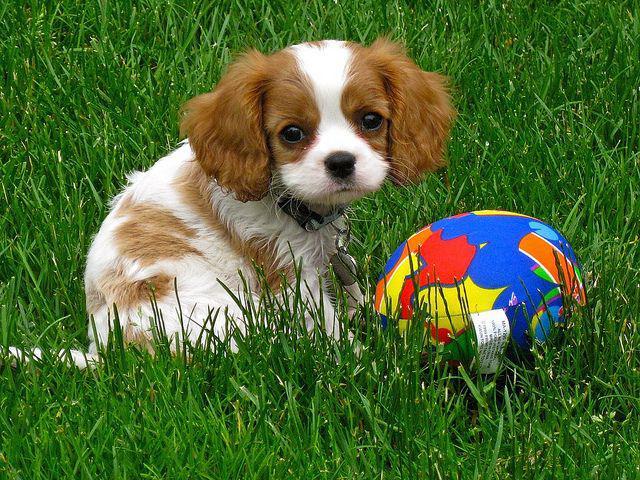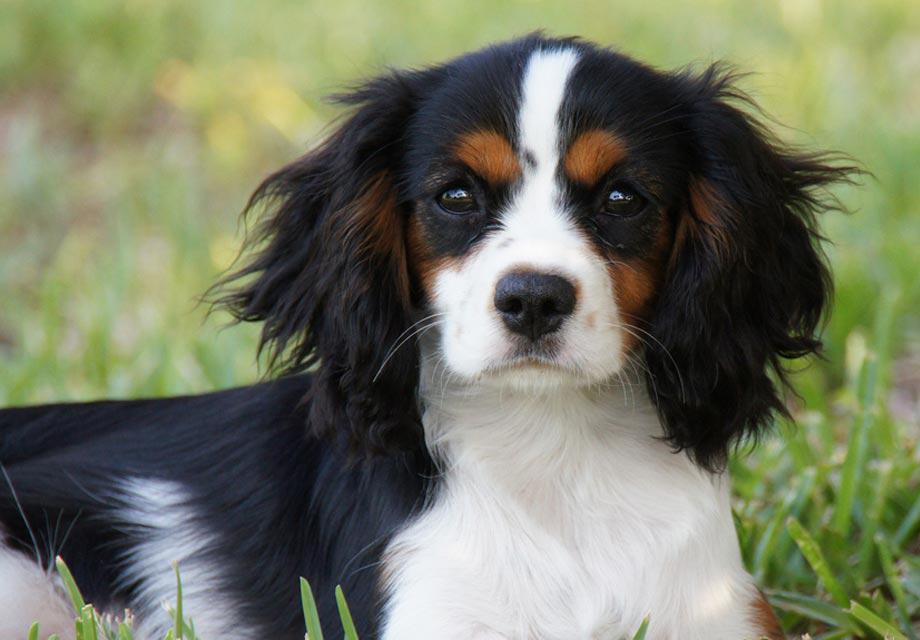The first image is the image on the left, the second image is the image on the right. Analyze the images presented: Is the assertion "One of the images shows an inanimate object with the dog." valid? Answer yes or no. Yes. 